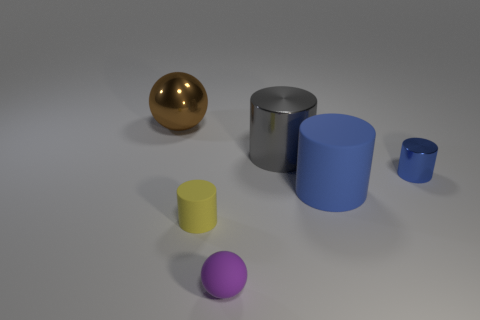What color is the tiny thing behind the tiny rubber object on the left side of the sphere in front of the big brown object?
Offer a very short reply. Blue. What number of other things are the same color as the big matte cylinder?
Ensure brevity in your answer.  1. How many metallic things are brown balls or big cylinders?
Give a very brief answer. 2. There is a small object to the left of the tiny sphere; is its color the same as the big cylinder that is to the right of the gray cylinder?
Offer a very short reply. No. Is there anything else that has the same material as the small purple thing?
Provide a short and direct response. Yes. What is the size of the other thing that is the same shape as the brown thing?
Provide a short and direct response. Small. Are there more blue metal objects that are right of the yellow object than small rubber objects?
Offer a very short reply. No. Is the tiny cylinder that is to the right of the yellow matte object made of the same material as the purple sphere?
Make the answer very short. No. There is a sphere in front of the sphere on the left side of the tiny matte object behind the purple matte thing; how big is it?
Keep it short and to the point. Small. The blue cylinder that is the same material as the brown sphere is what size?
Give a very brief answer. Small. 